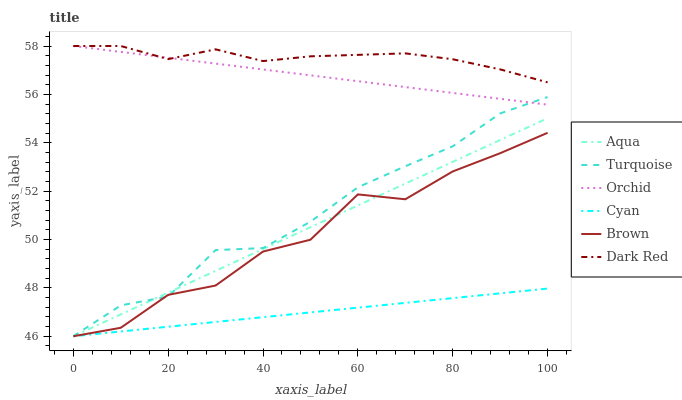Does Cyan have the minimum area under the curve?
Answer yes or no. Yes. Does Dark Red have the maximum area under the curve?
Answer yes or no. Yes. Does Turquoise have the minimum area under the curve?
Answer yes or no. No. Does Turquoise have the maximum area under the curve?
Answer yes or no. No. Is Cyan the smoothest?
Answer yes or no. Yes. Is Brown the roughest?
Answer yes or no. Yes. Is Turquoise the smoothest?
Answer yes or no. No. Is Turquoise the roughest?
Answer yes or no. No. Does Brown have the lowest value?
Answer yes or no. Yes. Does Dark Red have the lowest value?
Answer yes or no. No. Does Orchid have the highest value?
Answer yes or no. Yes. Does Turquoise have the highest value?
Answer yes or no. No. Is Brown less than Orchid?
Answer yes or no. Yes. Is Orchid greater than Aqua?
Answer yes or no. Yes. Does Dark Red intersect Orchid?
Answer yes or no. Yes. Is Dark Red less than Orchid?
Answer yes or no. No. Is Dark Red greater than Orchid?
Answer yes or no. No. Does Brown intersect Orchid?
Answer yes or no. No. 